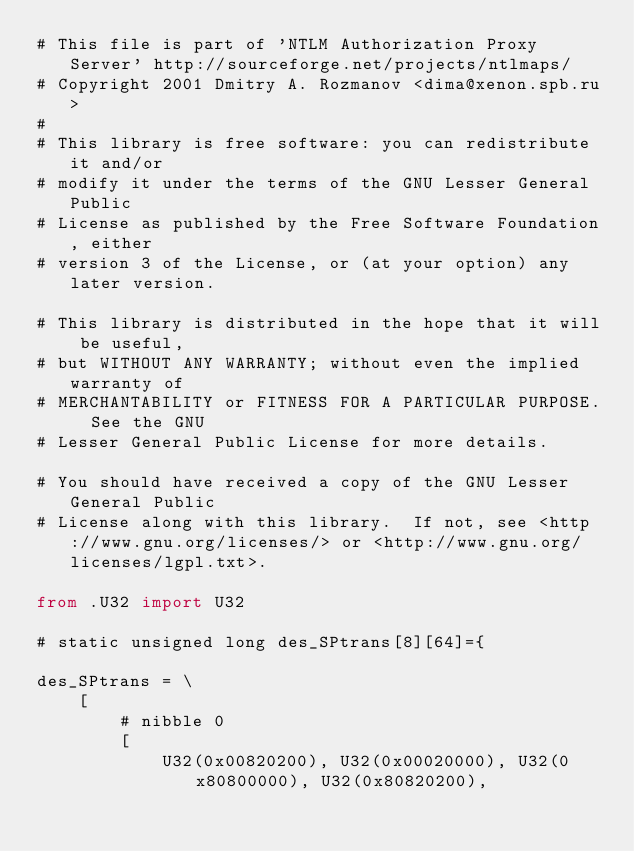<code> <loc_0><loc_0><loc_500><loc_500><_Python_># This file is part of 'NTLM Authorization Proxy Server' http://sourceforge.net/projects/ntlmaps/
# Copyright 2001 Dmitry A. Rozmanov <dima@xenon.spb.ru>
#
# This library is free software: you can redistribute it and/or
# modify it under the terms of the GNU Lesser General Public
# License as published by the Free Software Foundation, either
# version 3 of the License, or (at your option) any later version.

# This library is distributed in the hope that it will be useful,
# but WITHOUT ANY WARRANTY; without even the implied warranty of
# MERCHANTABILITY or FITNESS FOR A PARTICULAR PURPOSE.  See the GNU
# Lesser General Public License for more details.

# You should have received a copy of the GNU Lesser General Public
# License along with this library.  If not, see <http://www.gnu.org/licenses/> or <http://www.gnu.org/licenses/lgpl.txt>.

from .U32 import U32

# static unsigned long des_SPtrans[8][64]={

des_SPtrans = \
    [
        # nibble 0
        [
            U32(0x00820200), U32(0x00020000), U32(0x80800000), U32(0x80820200),</code> 